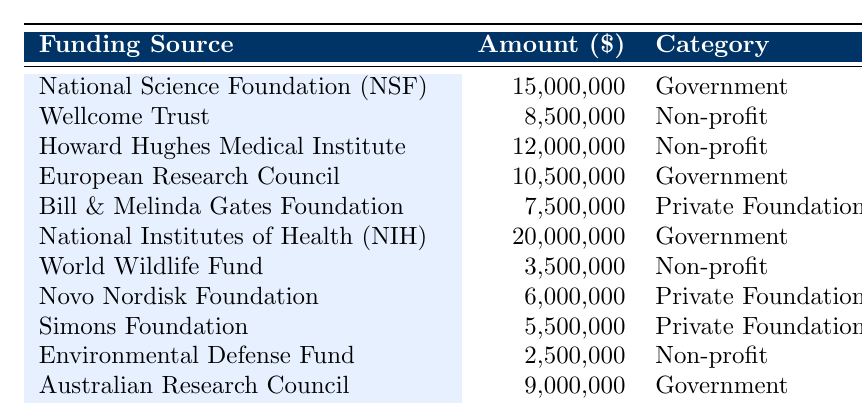What is the largest single funding source listed in the table? The table lists multiple funding sources with their amounts. By scanning through the "Amount" column, the largest value is 20,000,000 from the National Institutes of Health (NIH).
Answer: 20,000,000 Which category has the highest total funding when amounts are summed? To find the total funding per category: Government: 15,000,000 + 10,500,000 + 20,000,000 + 9,000,000 = 54,500,000; Non-profit: 8,500,000 + 12,000,000 + 3,500,000 + 2,500,000 = 26,500,000; Private Foundation: 7,500,000 + 6,000,000 + 5,500,000 + 4,500,000 = 23,500,000. The Government category has the highest total.
Answer: Government Is the Wellcome Trust the only funding source in the Non-profit category? Scanning the Non-profit category, we find four sources listed: Wellcome Trust, Howard Hughes Medical Institute, World Wildlife Fund, and Environmental Defense Fund. Therefore, Wellcome Trust is not the only one.
Answer: No What is the combined funding amount from all Private Foundation sources? From the table, the amounts for Private Foundations are: 7,500,000 + 6,000,000 + 5,500,000 + 4,500,000 = 23,500,000. Thus, the combined amount for Private Foundations is 23,500,000.
Answer: 23,500,000 Which funding source is categorized as a Non-profit and has the second highest amount? Listing the Non-profit sources by amount: Howard Hughes Medical Institute (12,000,000), Wellcome Trust (8,500,000), World Wildlife Fund (3,500,000), Environmental Defense Fund (2,500,000). The second highest is Wellcome Trust with 8,500,000.
Answer: Wellcome Trust What percentage of the total funding is from the National Science Foundation (NSF)? Total funding from all sources is 20,000,000 + 15,000,000 + 12,000,000 + 10,500,000 + 8,500,000 + 7,500,000 + 6,000,000 + 5,500,000 + 4,500,000 + 3,500,000 + 2,500,000 + 9,000,000 = 100,000,000. NSF represents 15,000,000, so (15,000,000 / 100,000,000) x 100 = 15%.
Answer: 15% How many funding sources have amounts greater than 5 million? Reviewing the table, the amounts greater than 5 million are: 20,000,000 (NIH), 15,000,000 (NSF), 12,000,000 (Howard Hughes), 10,500,000 (ERC), 9,000,000 (ARC), 8,500,000 (Wellcome Trust), and 7,500,000 (Gates). This results in 7 sources.
Answer: 7 